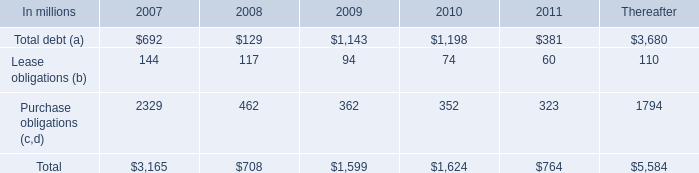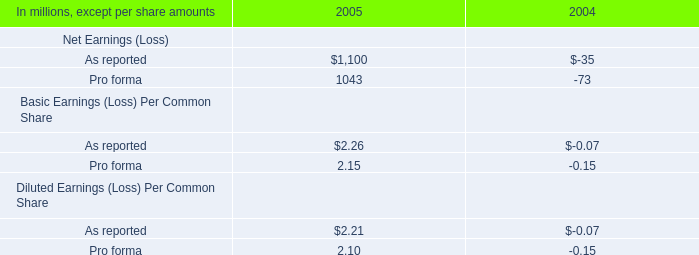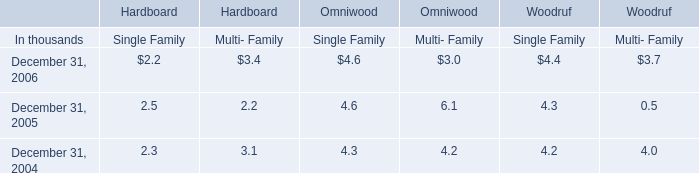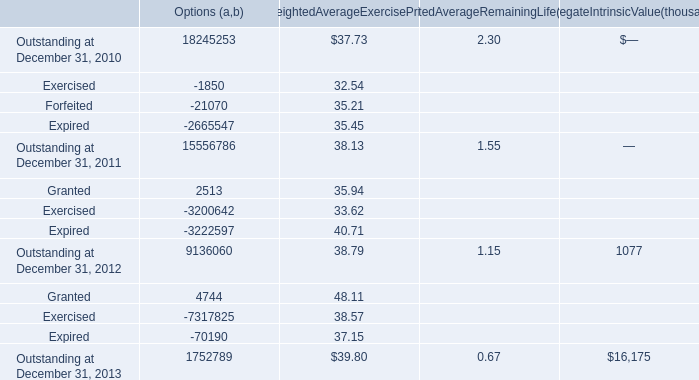Which year is Outstanding at December 31, 2011 the highest? 
Answer: 2010. 